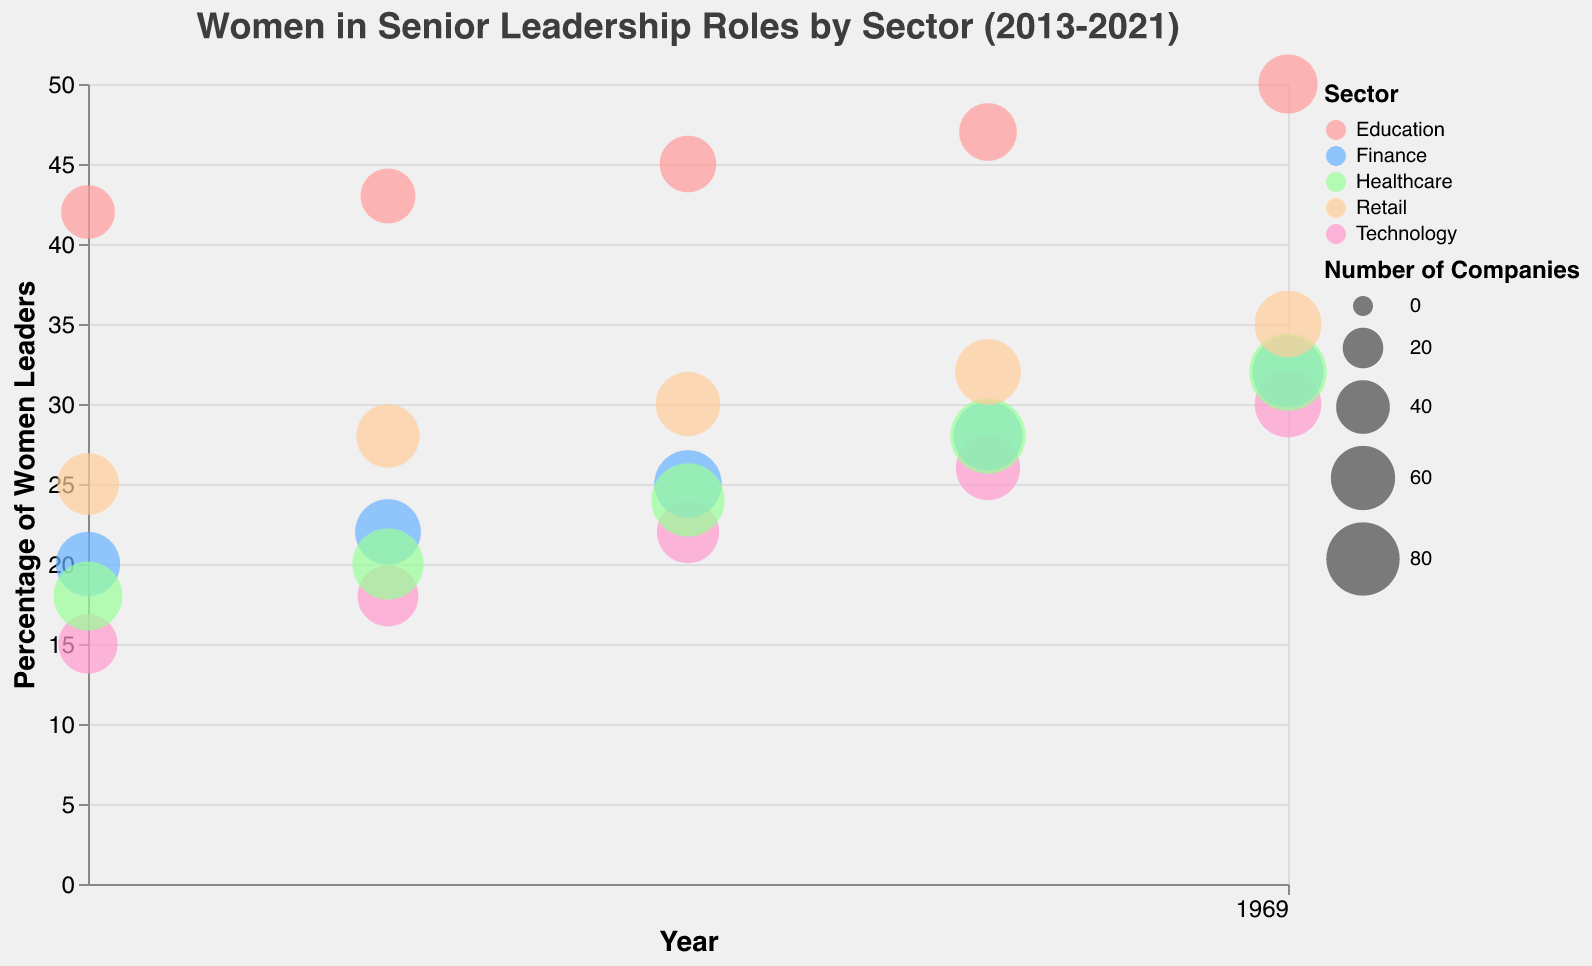What is the title of the bubble chart? The title is placed at the top of the chart and summarizes the main focus of the visual representation. It reads, "Women in Senior Leadership Roles by Sector (2013-2021)."
Answer: Women in Senior Leadership Roles by Sector (2013-2021) Which sector had the highest percentage of women leaders in 2021? By observing the y-axis and finding the bubble positioned at the highest point for the year 2021, we can determine that the sector with the highest percentage of women leaders is Education.
Answer: Education How has the percentage of women leaders in the Retail sector changed from 2013 to 2021? By locating the bubbles representing the Retail sector along the x-axis from 2013 to 2021, we can observe that the percentage of women leaders has increased from 25% in 2013 to 35% in 2021.
Answer: Increased by 10% How many companies in the Healthcare sector were included in the analysis for the year 2019? Looking at the tooltip for the Healthcare sector bubble in the year 2019 will reveal that the number of companies analyzed was 85.
Answer: 85 Which sector shows the most substantial increase in the percentage of women leaders from 2013 to 2021? To find this, we compare the starting and ending values for each sector over the given years. The Education sector shows an increase from 42% in 2013 to 50% in 2021, which is an increment of 8%. Calculating the increases for Technology, Finance, Healthcare, and Retail shows they have smaller increases, making Education the one with the most substantial rise.
Answer: Education What is the average age of leaders in the Finance sector in the year 2021? Check the tooltip for the Finance sector bubble in the year 2021 to see that the average age of leaders is 54.
Answer: 54 Compare the size of the bubbles for Technology and Healthcare in 2021; which sector has more companies represented? The size of the bubble represents the number of companies. By comparing the sizes, we can see that the Healthcare sector has a larger bubble than the Technology sector in 2021.
Answer: Healthcare What is the overall trend in the percentage of women leaders across all sectors from 2013 to 2021? By looking at the trend of the bubbles for each sector across the x-axis, we can observe that the percentage of women leaders has generally increased in all sectors from 2013 to 2021.
Answer: Increasing Between 2015 and 2017, which sector showed the highest increase in the percentage of women leaders? Calculate the percentage increase for each sector by subtracting the 2015 values from the 2017 values. Technology increased by 4%, Finance by 3%, Healthcare by 4%, Education by 2%, and Retail by 2%. Therefore, both Technology and Healthcare showed the highest increase with 4%.
Answer: Technology and Healthcare 